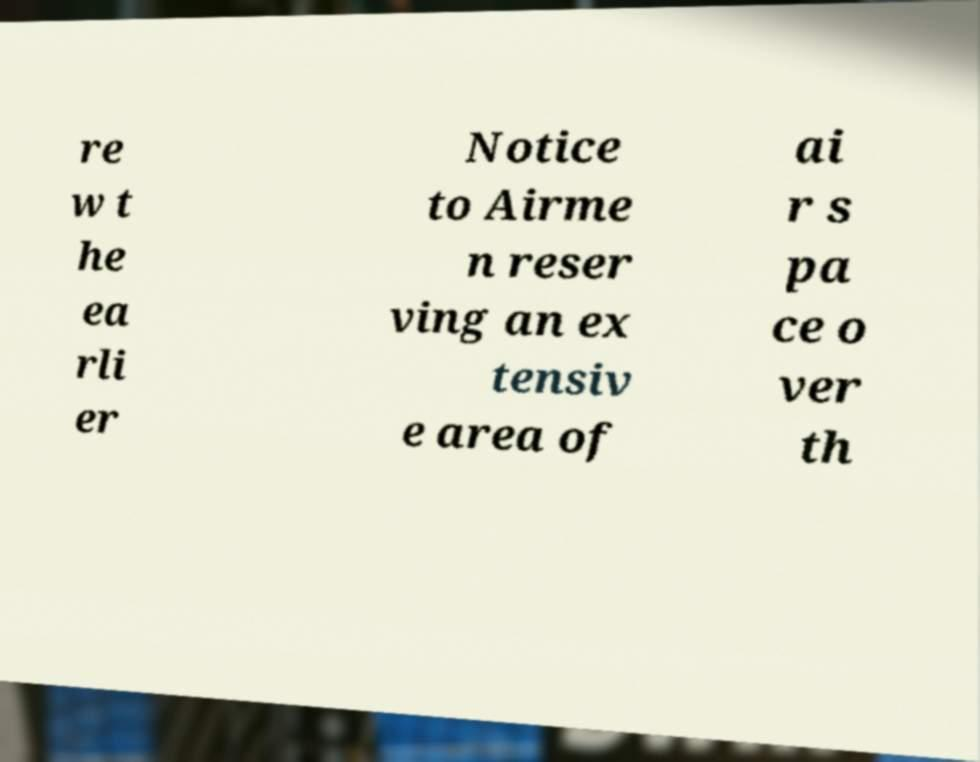For documentation purposes, I need the text within this image transcribed. Could you provide that? re w t he ea rli er Notice to Airme n reser ving an ex tensiv e area of ai r s pa ce o ver th 